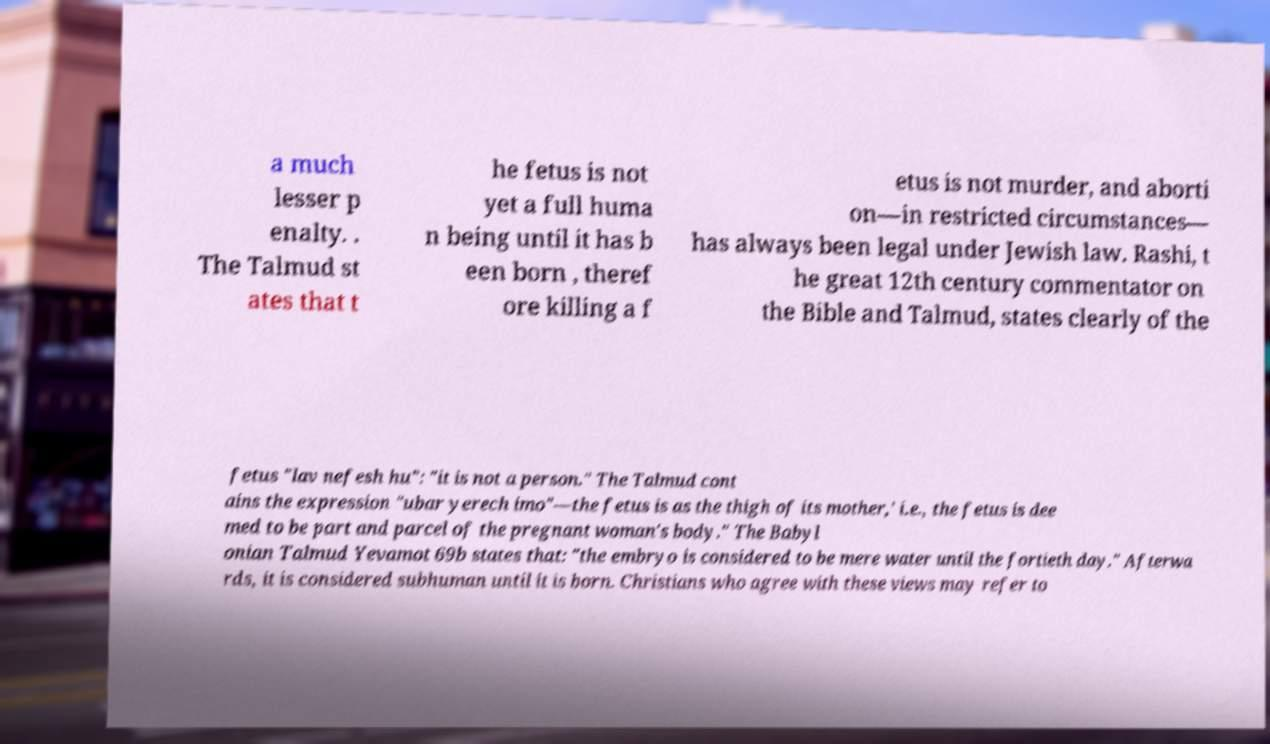Please identify and transcribe the text found in this image. a much lesser p enalty. . The Talmud st ates that t he fetus is not yet a full huma n being until it has b een born , theref ore killing a f etus is not murder, and aborti on—in restricted circumstances— has always been legal under Jewish law. Rashi, t he great 12th century commentator on the Bible and Talmud, states clearly of the fetus "lav nefesh hu": "it is not a person." The Talmud cont ains the expression "ubar yerech imo"—the fetus is as the thigh of its mother,' i.e., the fetus is dee med to be part and parcel of the pregnant woman's body." The Babyl onian Talmud Yevamot 69b states that: "the embryo is considered to be mere water until the fortieth day." Afterwa rds, it is considered subhuman until it is born. Christians who agree with these views may refer to 